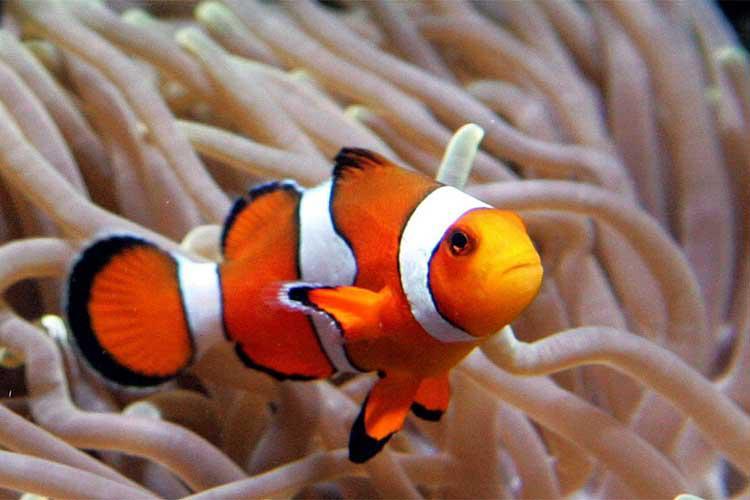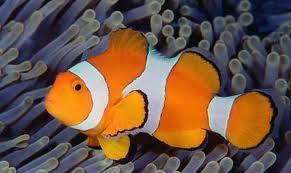The first image is the image on the left, the second image is the image on the right. Evaluate the accuracy of this statement regarding the images: "Exactly two clown-fish are interacting with an anemone in the left photo while exactly one fish is within the orange colored anemone in the right photo.". Is it true? Answer yes or no. No. The first image is the image on the left, the second image is the image on the right. For the images shown, is this caption "The left image features exactly two clown fish swimming in anemone tendrils, and the right image features one fish swimming in a different color of anemone tendrils." true? Answer yes or no. No. 